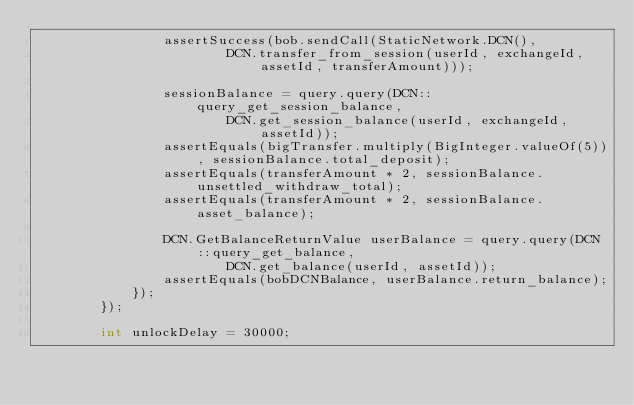<code> <loc_0><loc_0><loc_500><loc_500><_Java_>                assertSuccess(bob.sendCall(StaticNetwork.DCN(),
                        DCN.transfer_from_session(userId, exchangeId, assetId, transferAmount)));

                sessionBalance = query.query(DCN::query_get_session_balance,
                        DCN.get_session_balance(userId, exchangeId, assetId));
                assertEquals(bigTransfer.multiply(BigInteger.valueOf(5)), sessionBalance.total_deposit);
                assertEquals(transferAmount * 2, sessionBalance.unsettled_withdraw_total);
                assertEquals(transferAmount * 2, sessionBalance.asset_balance);

                DCN.GetBalanceReturnValue userBalance = query.query(DCN::query_get_balance,
                        DCN.get_balance(userId, assetId));
                assertEquals(bobDCNBalance, userBalance.return_balance);
            });
        });

        int unlockDelay = 30000;
</code> 